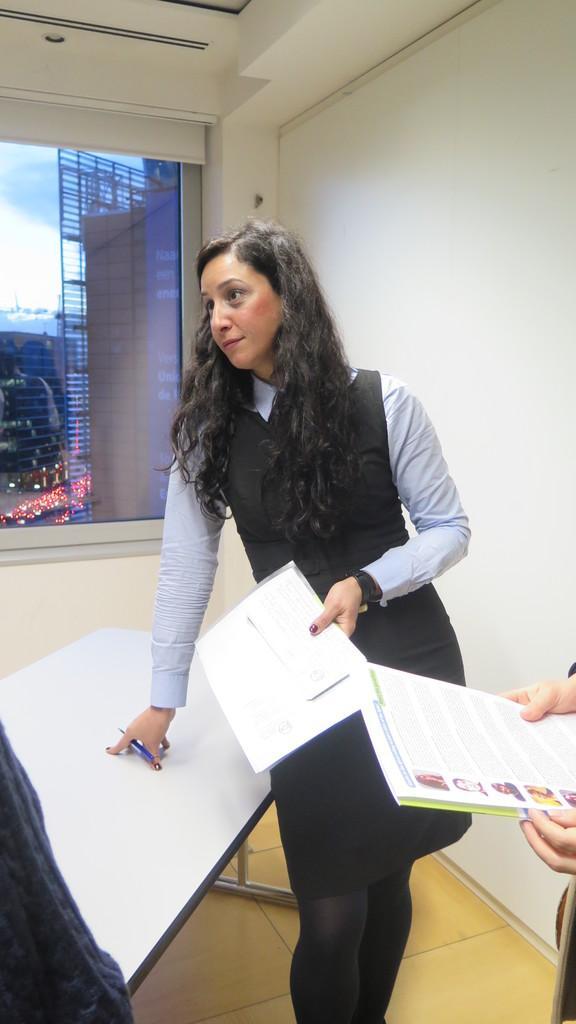Can you describe this image briefly? In the center of the image, we can see a lady holding some papers and a pen and on the right, there is a person holding a book and we can see a board and there is an other person and there is a window and through the glass we can see some buildings, lights and vehicles on the road. At the bottom, there is a floor. 